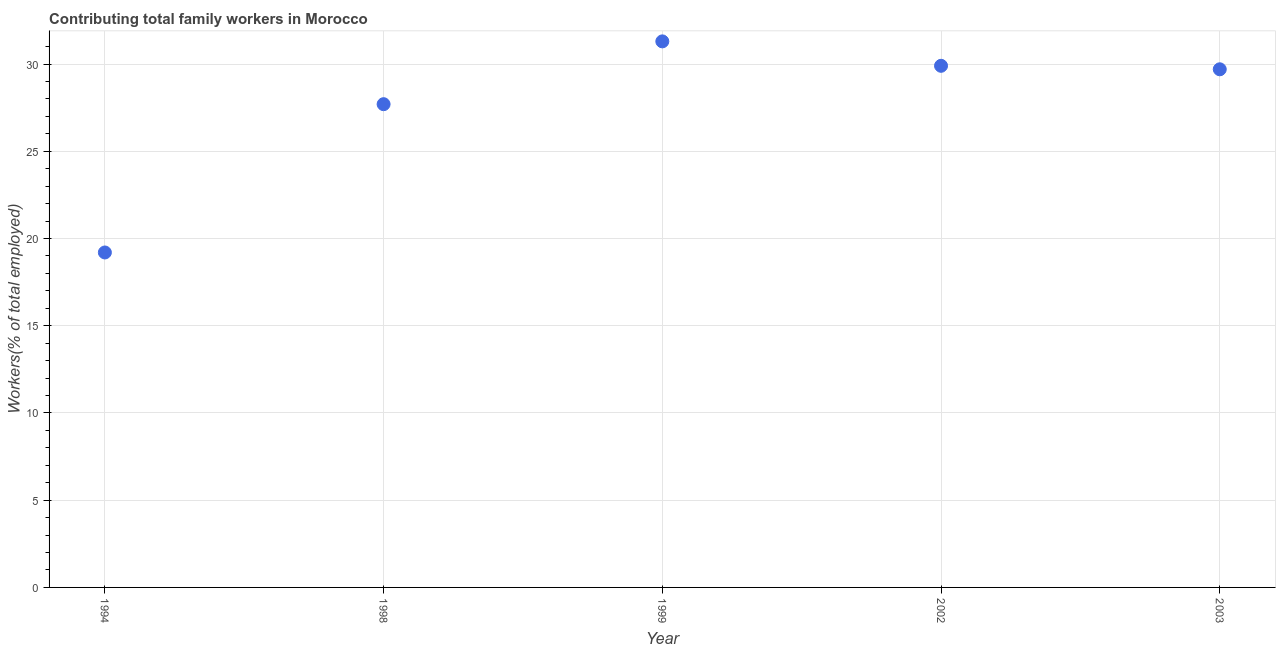What is the contributing family workers in 1994?
Your response must be concise. 19.2. Across all years, what is the maximum contributing family workers?
Provide a succinct answer. 31.3. Across all years, what is the minimum contributing family workers?
Keep it short and to the point. 19.2. What is the sum of the contributing family workers?
Provide a short and direct response. 137.8. What is the difference between the contributing family workers in 2002 and 2003?
Offer a very short reply. 0.2. What is the average contributing family workers per year?
Offer a terse response. 27.56. What is the median contributing family workers?
Your answer should be compact. 29.7. In how many years, is the contributing family workers greater than 7 %?
Your response must be concise. 5. What is the ratio of the contributing family workers in 1994 to that in 1999?
Ensure brevity in your answer.  0.61. Is the contributing family workers in 1998 less than that in 2003?
Offer a very short reply. Yes. What is the difference between the highest and the second highest contributing family workers?
Your answer should be very brief. 1.4. Is the sum of the contributing family workers in 1994 and 1999 greater than the maximum contributing family workers across all years?
Offer a terse response. Yes. What is the difference between the highest and the lowest contributing family workers?
Your response must be concise. 12.1. In how many years, is the contributing family workers greater than the average contributing family workers taken over all years?
Keep it short and to the point. 4. Does the contributing family workers monotonically increase over the years?
Give a very brief answer. No. What is the title of the graph?
Give a very brief answer. Contributing total family workers in Morocco. What is the label or title of the Y-axis?
Provide a short and direct response. Workers(% of total employed). What is the Workers(% of total employed) in 1994?
Offer a terse response. 19.2. What is the Workers(% of total employed) in 1998?
Offer a very short reply. 27.7. What is the Workers(% of total employed) in 1999?
Ensure brevity in your answer.  31.3. What is the Workers(% of total employed) in 2002?
Offer a very short reply. 29.9. What is the Workers(% of total employed) in 2003?
Provide a succinct answer. 29.7. What is the difference between the Workers(% of total employed) in 1994 and 1998?
Keep it short and to the point. -8.5. What is the difference between the Workers(% of total employed) in 1994 and 2003?
Your answer should be compact. -10.5. What is the difference between the Workers(% of total employed) in 1998 and 2003?
Offer a terse response. -2. What is the ratio of the Workers(% of total employed) in 1994 to that in 1998?
Offer a terse response. 0.69. What is the ratio of the Workers(% of total employed) in 1994 to that in 1999?
Offer a terse response. 0.61. What is the ratio of the Workers(% of total employed) in 1994 to that in 2002?
Provide a short and direct response. 0.64. What is the ratio of the Workers(% of total employed) in 1994 to that in 2003?
Make the answer very short. 0.65. What is the ratio of the Workers(% of total employed) in 1998 to that in 1999?
Your response must be concise. 0.89. What is the ratio of the Workers(% of total employed) in 1998 to that in 2002?
Offer a very short reply. 0.93. What is the ratio of the Workers(% of total employed) in 1998 to that in 2003?
Provide a short and direct response. 0.93. What is the ratio of the Workers(% of total employed) in 1999 to that in 2002?
Your answer should be very brief. 1.05. What is the ratio of the Workers(% of total employed) in 1999 to that in 2003?
Your answer should be compact. 1.05. What is the ratio of the Workers(% of total employed) in 2002 to that in 2003?
Give a very brief answer. 1.01. 